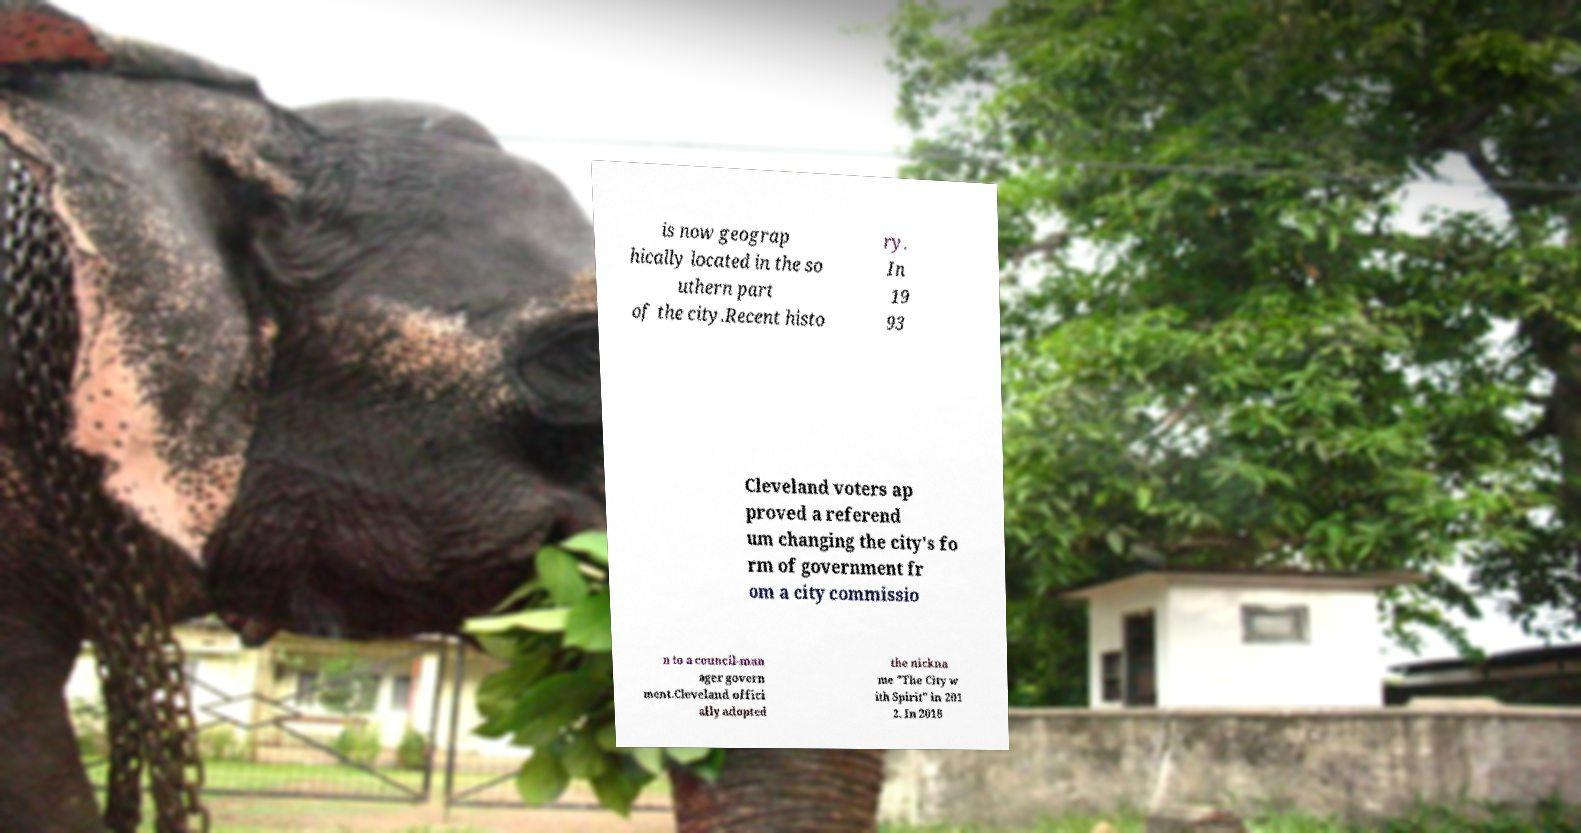There's text embedded in this image that I need extracted. Can you transcribe it verbatim? is now geograp hically located in the so uthern part of the city.Recent histo ry. In 19 93 Cleveland voters ap proved a referend um changing the city's fo rm of government fr om a city commissio n to a council-man ager govern ment.Cleveland offici ally adopted the nickna me "The City w ith Spirit" in 201 2. In 2018 